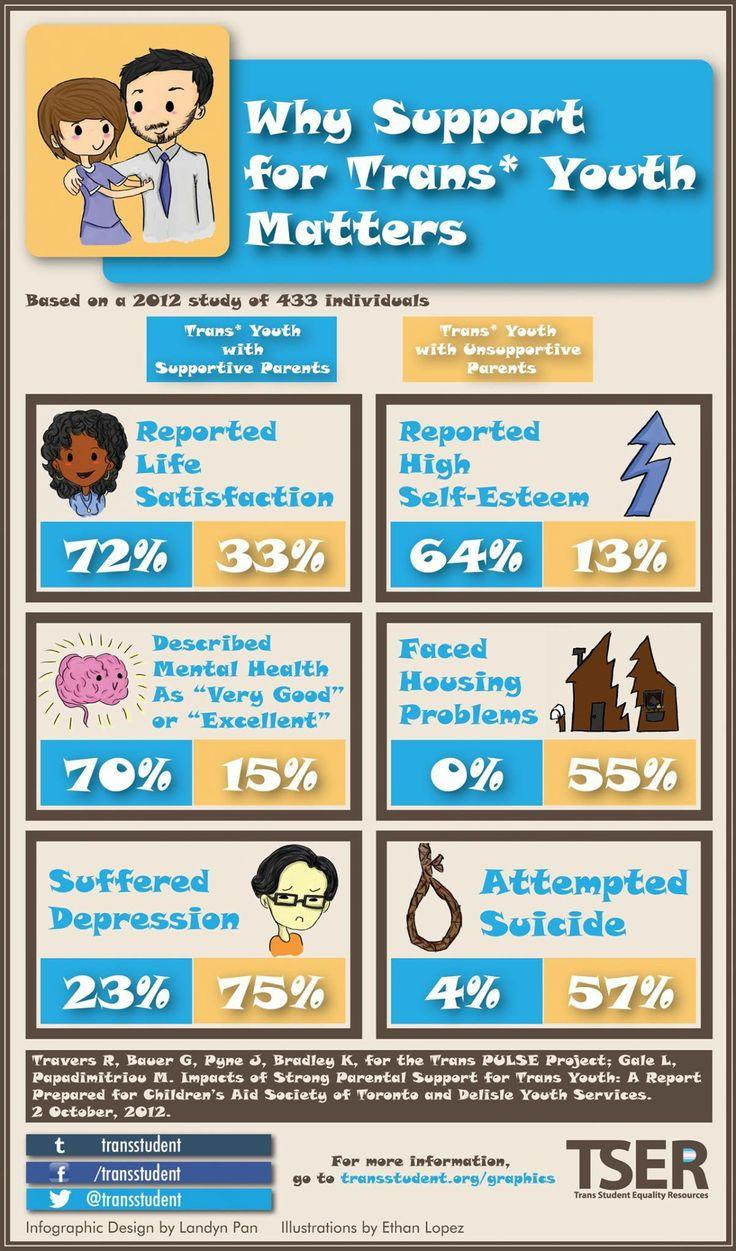Draw attention to some important aspects in this diagram. According to the data, not a single trans youth with supportive parents reported facing housing problems. According to the study, 28% of trans youth who reported having supportive parents did not report high levels of self-satisfaction. A recent study found that 33% of trans youth reported dissatisfaction with their parents' support. According to the survey, a significant percentage, or 55%, of trans youth who lack support from their parents reported experiencing housing problems. According to a survey of trans youth, 64% reported that having supportive parents improved their self-esteem. 